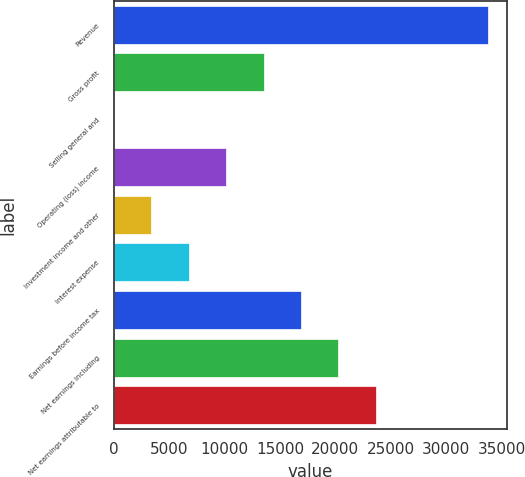<chart> <loc_0><loc_0><loc_500><loc_500><bar_chart><fcel>Revenue<fcel>Gross profit<fcel>Selling general and<fcel>Operating (loss) income<fcel>Investment income and other<fcel>Interest expense<fcel>Earnings before income tax<fcel>Net earnings including<fcel>Net earnings attributable to<nl><fcel>33762<fcel>13508.4<fcel>6<fcel>10132.8<fcel>3381.6<fcel>6757.2<fcel>16884<fcel>20259.6<fcel>23635.2<nl></chart> 